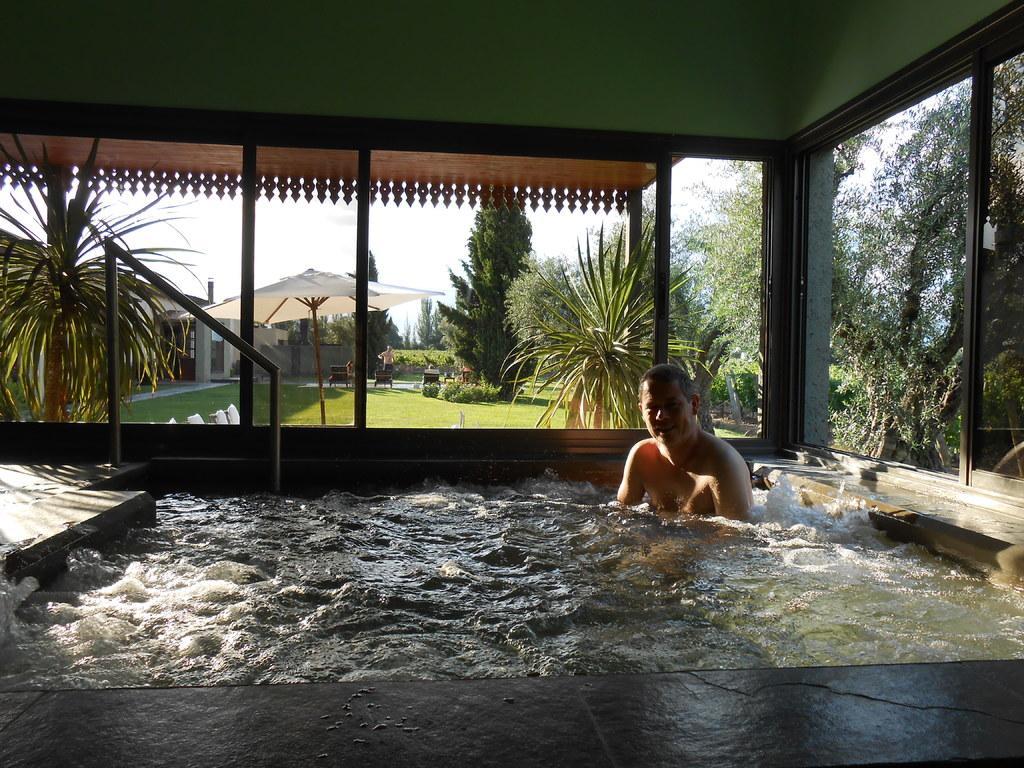Could you give a brief overview of what you see in this image? There is a man in the swimming pool. There is a railing. The pool is in a closed room. We can observe trees in the background and an umbrella. There is a lawn outside the room and we can observe sky too. 